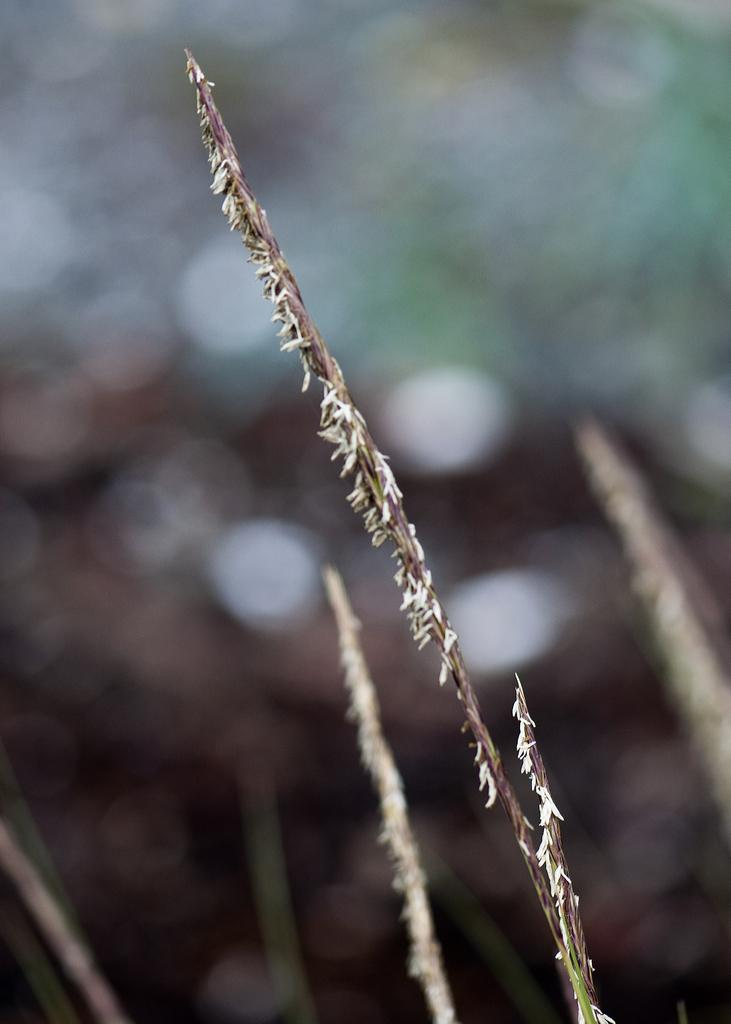What is the main subject of the picture? The main subject of the picture is a stem of a plant. Can you describe the background of the image? The background image is blurred. What type of bird can be seen in the market in the image? There is no bird or market present in the image; it features a stem of a plant with a blurred background. Who is the owner of the plant in the image? There is no information about the owner of the plant in the image. 